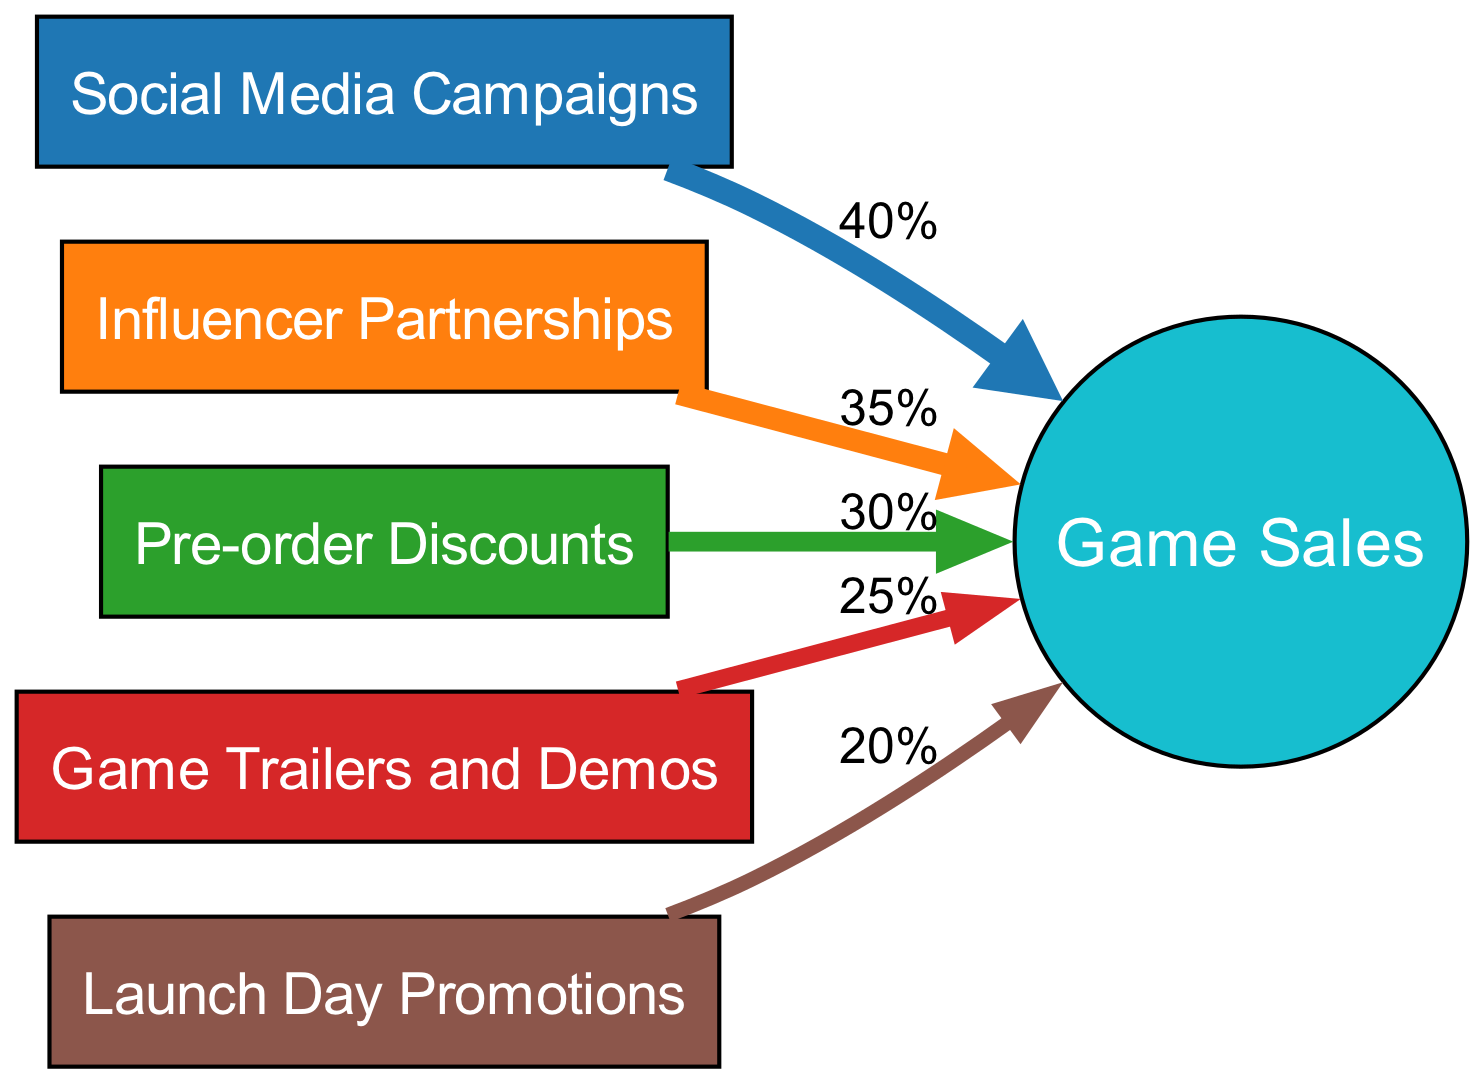What is the value associated with Social Media Campaigns? The diagram shows that the width of the flow from the node "Social Media Campaigns" to "Game Sales" is 40%, which indicates that this strategy contributed 40% to game sales in the quarter.
Answer: 40% Which marketing strategy had the highest impact on game sales? The largest width of the flow in the diagram indicates that "Social Media Campaigns" had the highest impact, with a contribution of 40%.
Answer: Social Media Campaigns How many marketing strategies are shown in the diagram? There are six nodes representing marketing strategies, including Social Media Campaigns, Influencer Partnerships, Pre-order Discounts, Game Trailers and Demos, and Launch Day Promotions.
Answer: 5 What is the total percentage contribution of Influencer Partnerships and Pre-order Discounts to game sales? The flow for "Influencer Partnerships" is 35% and "Pre-order Discounts" is 30%. Adding these together gives 35% + 30% = 65%.
Answer: 65% Which strategy is least effective based on the diagram? The flow leading from "Launch Day Promotions" to "Game Sales" is the smallest at 20%, suggesting it is the least effective strategy among those listed.
Answer: Launch Day Promotions What is the combined contribution of Game Trailers and Demos and Launch Day Promotions? The flow for "Game Trailers and Demos" is 25% and for "Launch Day Promotions" is 20%. Adding these percentages gives 25% + 20% = 45%.
Answer: 45% Which marketing strategy has a direct relationship with the node 'Game Sales'? All the marketing strategies listed have a direct relationship with "Game Sales" as they flow into this outcome node; however, the question can be interpreted to seek one specific entry. For instance, "Pre-order Discounts" directly connects and adds value.
Answer: Pre-order Discounts How many edges are represented in the flow of the diagram? The edges represent the connections from each marketing strategy to "Game Sales". There are five edges in total leading to the outcome.
Answer: 5 What percentage of the total sales does Game Trailers and Demos represent? The width of the flow from "Game Trailers and Demos" to "Game Sales" is 25%, indicating that this strategy represents 25% of total sales during the measured quarter.
Answer: 25% 